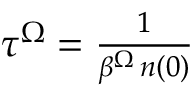<formula> <loc_0><loc_0><loc_500><loc_500>\begin{array} { r } { \tau ^ { \Omega } = \frac { 1 } { \beta ^ { \Omega } \, n ( 0 ) } } \end{array}</formula> 